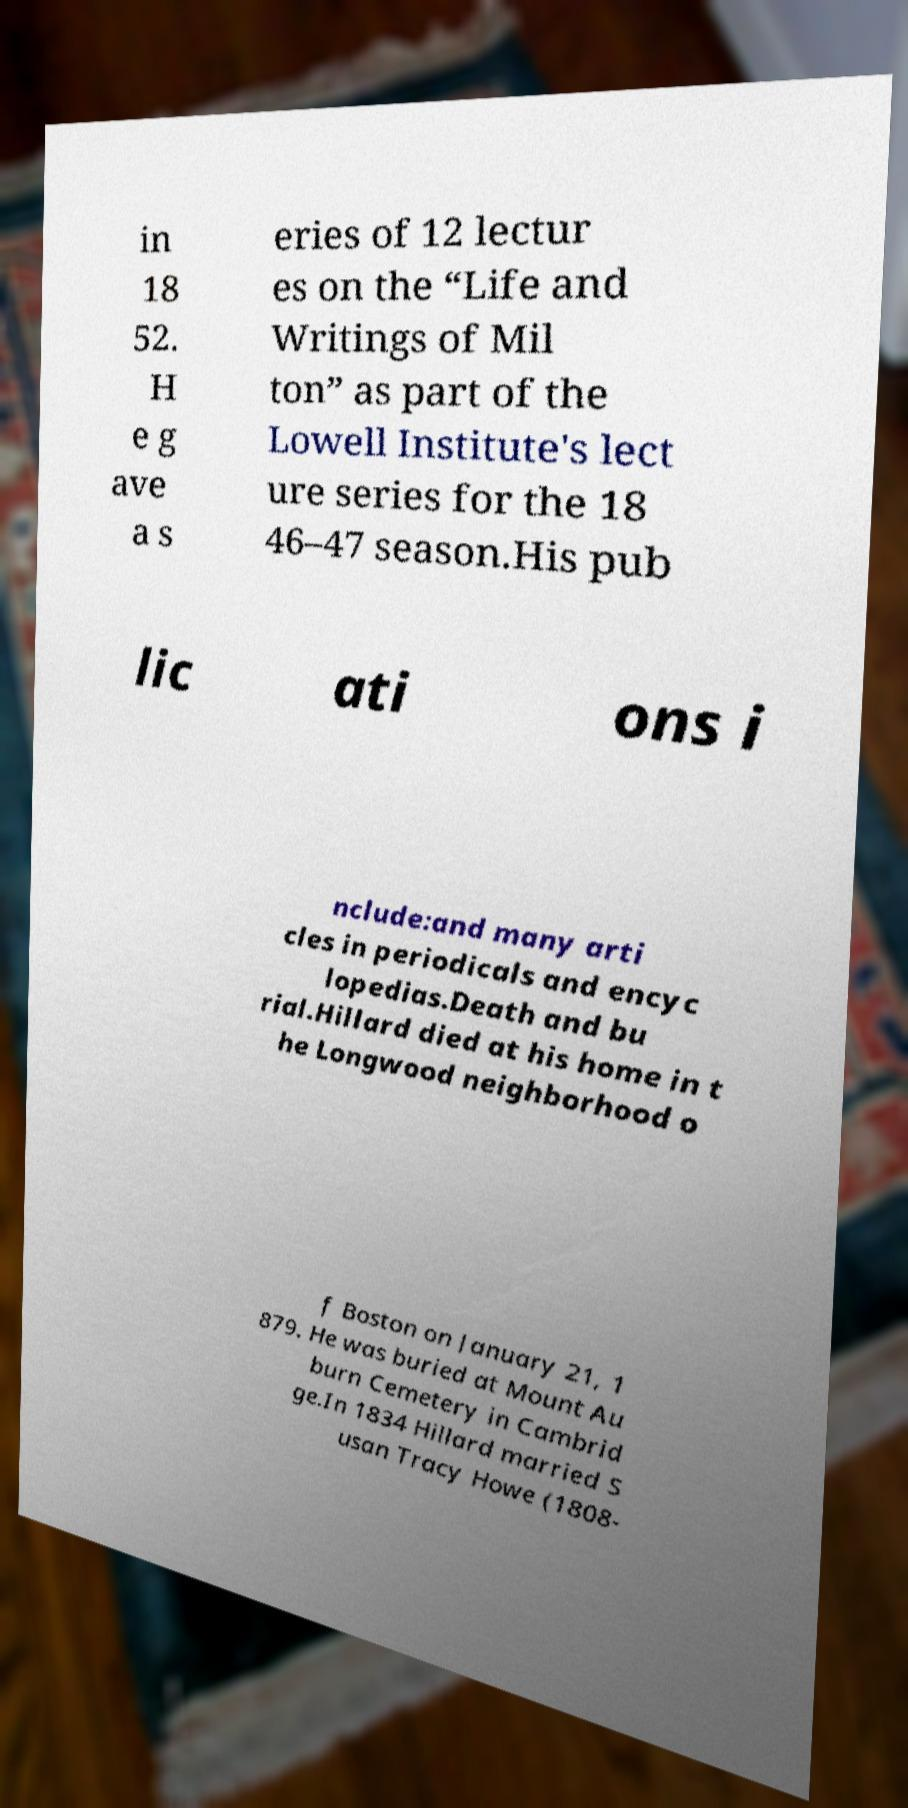I need the written content from this picture converted into text. Can you do that? in 18 52. H e g ave a s eries of 12 lectur es on the “Life and Writings of Mil ton” as part of the Lowell Institute's lect ure series for the 18 46–47 season.His pub lic ati ons i nclude:and many arti cles in periodicals and encyc lopedias.Death and bu rial.Hillard died at his home in t he Longwood neighborhood o f Boston on January 21, 1 879. He was buried at Mount Au burn Cemetery in Cambrid ge.In 1834 Hillard married S usan Tracy Howe (1808- 